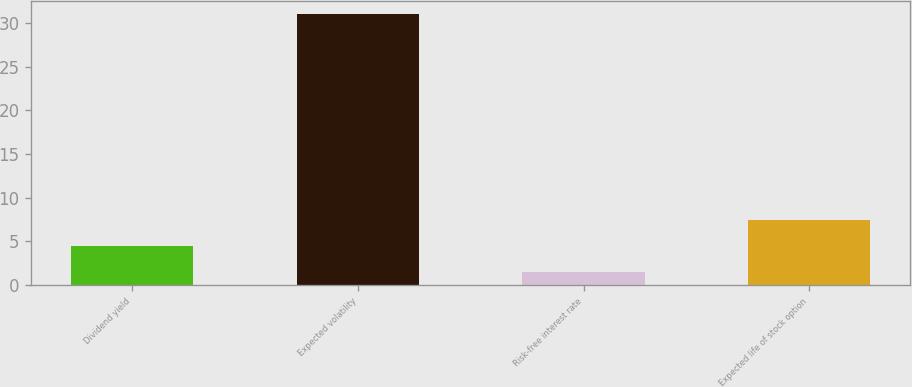Convert chart to OTSL. <chart><loc_0><loc_0><loc_500><loc_500><bar_chart><fcel>Dividend yield<fcel>Expected volatility<fcel>Risk-free interest rate<fcel>Expected life of stock option<nl><fcel>4.45<fcel>31<fcel>1.5<fcel>7.4<nl></chart> 